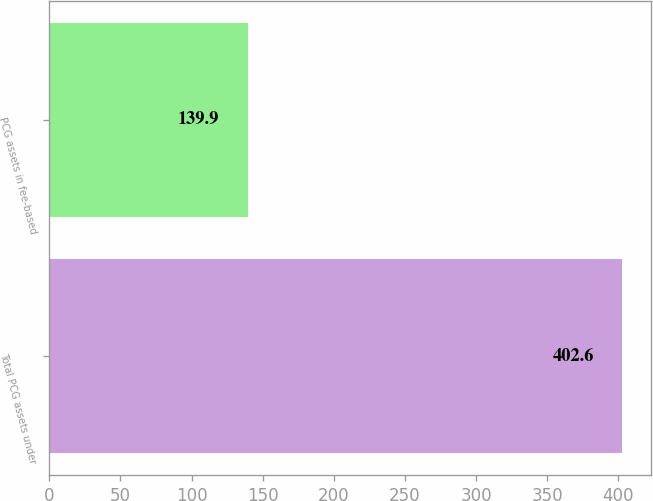Convert chart to OTSL. <chart><loc_0><loc_0><loc_500><loc_500><bar_chart><fcel>Total PCG assets under<fcel>PCG assets in fee-based<nl><fcel>402.6<fcel>139.9<nl></chart> 